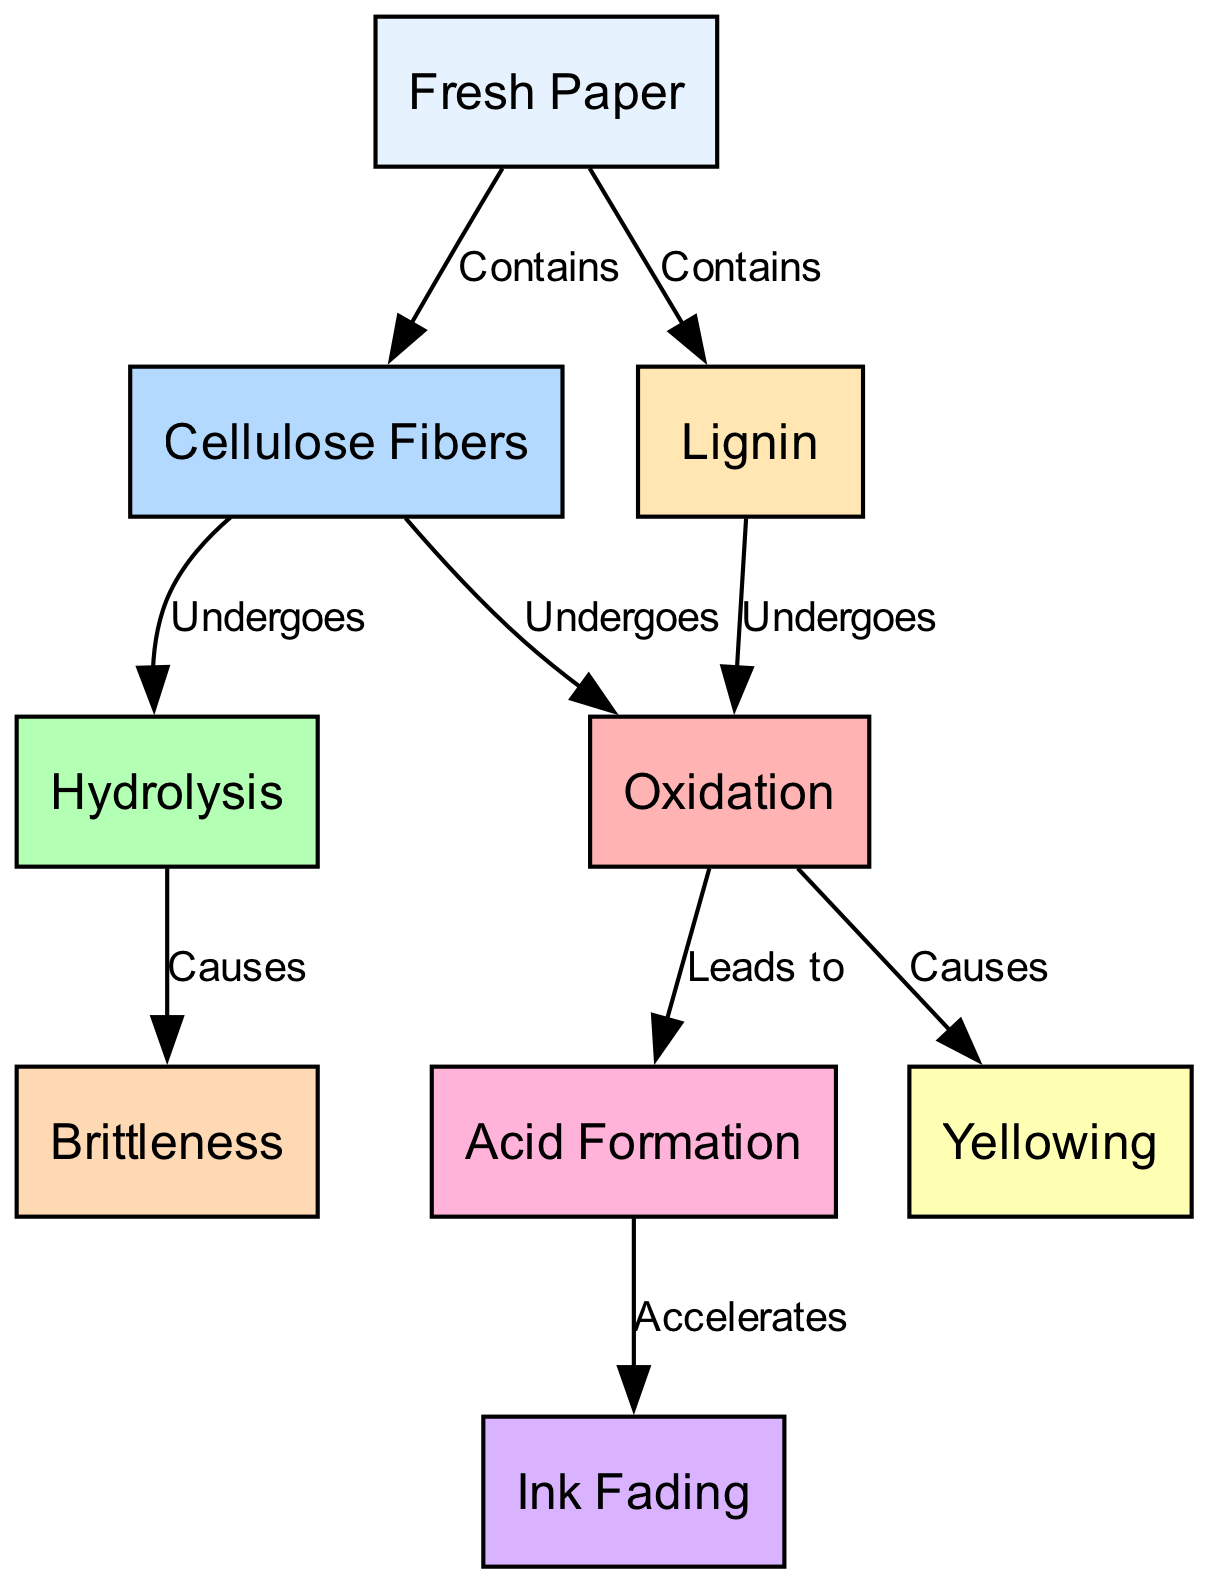What is the starting point of the paper aging process? The starting point is represented by the "Fresh Paper" node, which is where the process begins before it undergoes any aging changes.
Answer: Fresh Paper How many nodes are there in the diagram? By counting the "nodes" section of the data, there are a total of 9 nodes representing different stages or components in the paper aging process.
Answer: 9 What causes yellowing in paper? Yellowing is caused by the "Oxidation" node in the diagram, which indicates that this chemical change leads to yellowing of the paper over time.
Answer: Oxidation Which process leads to acid formation? The process that leads to acid formation is the "Oxidation" process, which is highlighted in the diagram as impacting subsequent chemical changes such as acid formation.
Answer: Oxidation What happens to cellulose fibers during the aging process? Cellulose fibers undergo oxidation and hydrolysis as they age, which are both initial processes that affect the overall chemical stability of the paper.
Answer: Undergoes oxidation and hydrolysis Which node represents the fading of ink? The "Ink Fading" node at the end of the diagram represents the fading of ink as a result of previous processes such as acid formation.
Answer: Ink Fading What is the relationship between hydrolysis and brittleness? Hydrolysis causes brittleness in paper, as represented by the directed edge in the diagram showing this cause-and-effect relationship.
Answer: Causes How does acid formation accelerate ink fading? Acid formation accelerates ink fading, as indicated by the directed edge between these two nodes, showing that the presence of acid hastens the fading of ink over time.
Answer: Accelerates What are the components found in fresh paper? Fresh paper contains "Cellulose Fibers" and "Lignin," as shown by the edges connecting the "Fresh Paper" node to these two components.
Answer: Cellulose Fibers and Lignin 